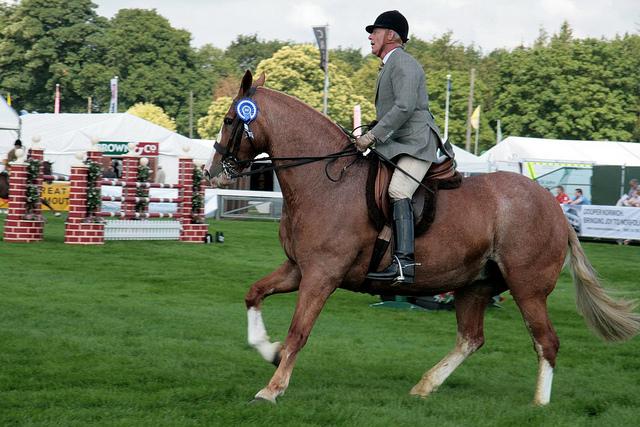Is this an equestrian event?
Keep it brief. Yes. What is this man riding on?
Quick response, please. Horse. What kind of boots does the man wear?
Be succinct. Riding. 